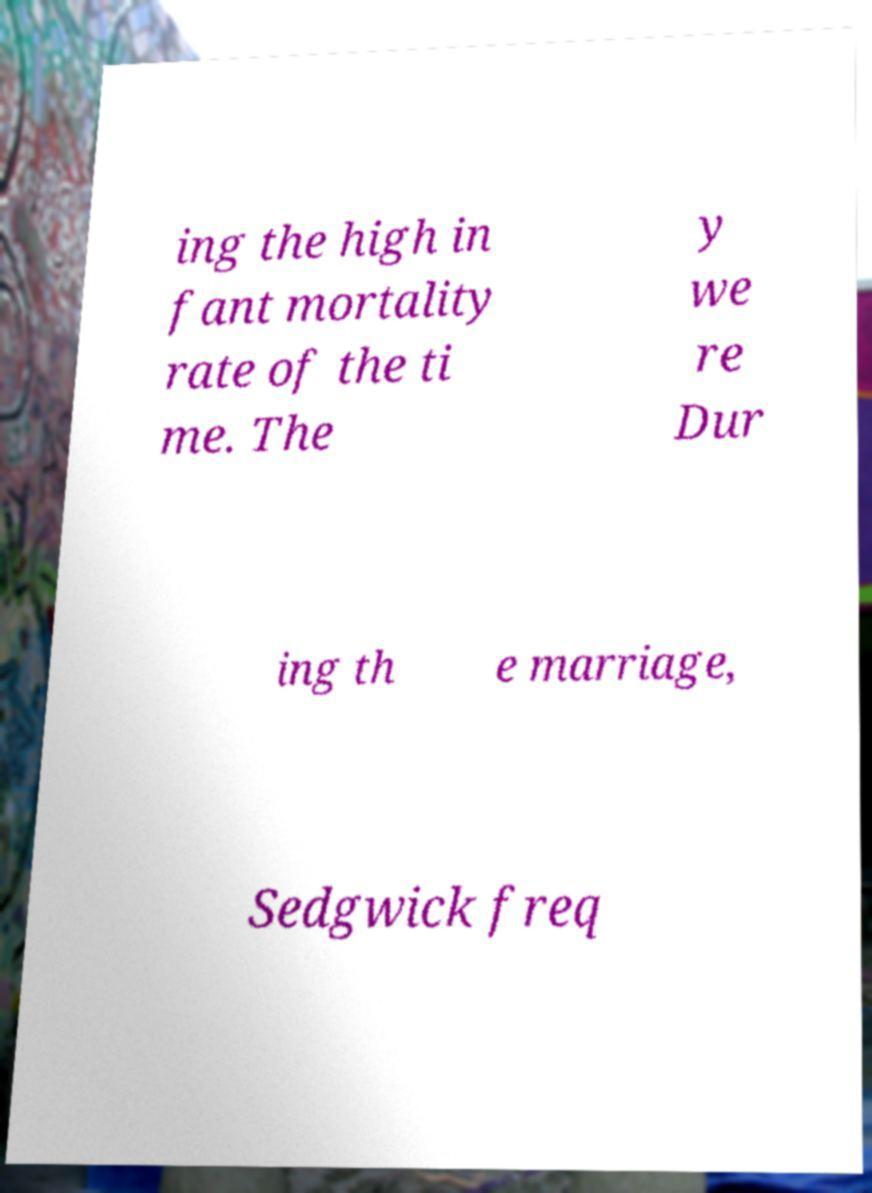Please read and relay the text visible in this image. What does it say? ing the high in fant mortality rate of the ti me. The y we re Dur ing th e marriage, Sedgwick freq 